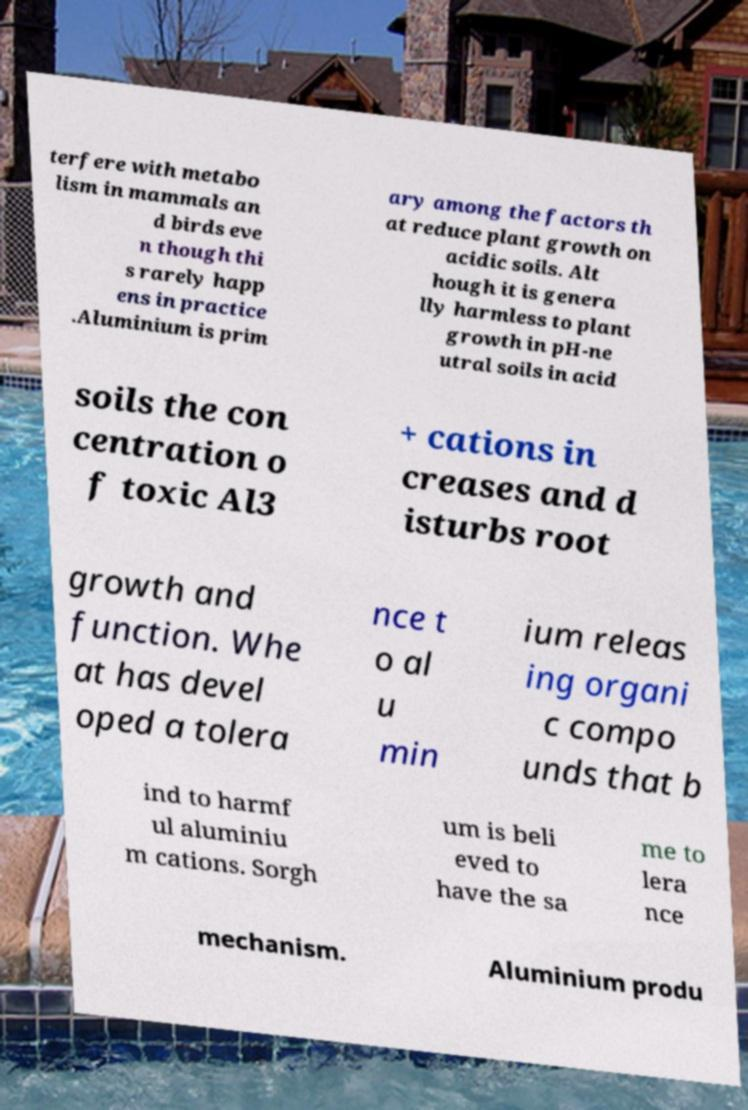Can you accurately transcribe the text from the provided image for me? terfere with metabo lism in mammals an d birds eve n though thi s rarely happ ens in practice .Aluminium is prim ary among the factors th at reduce plant growth on acidic soils. Alt hough it is genera lly harmless to plant growth in pH-ne utral soils in acid soils the con centration o f toxic Al3 + cations in creases and d isturbs root growth and function. Whe at has devel oped a tolera nce t o al u min ium releas ing organi c compo unds that b ind to harmf ul aluminiu m cations. Sorgh um is beli eved to have the sa me to lera nce mechanism. Aluminium produ 